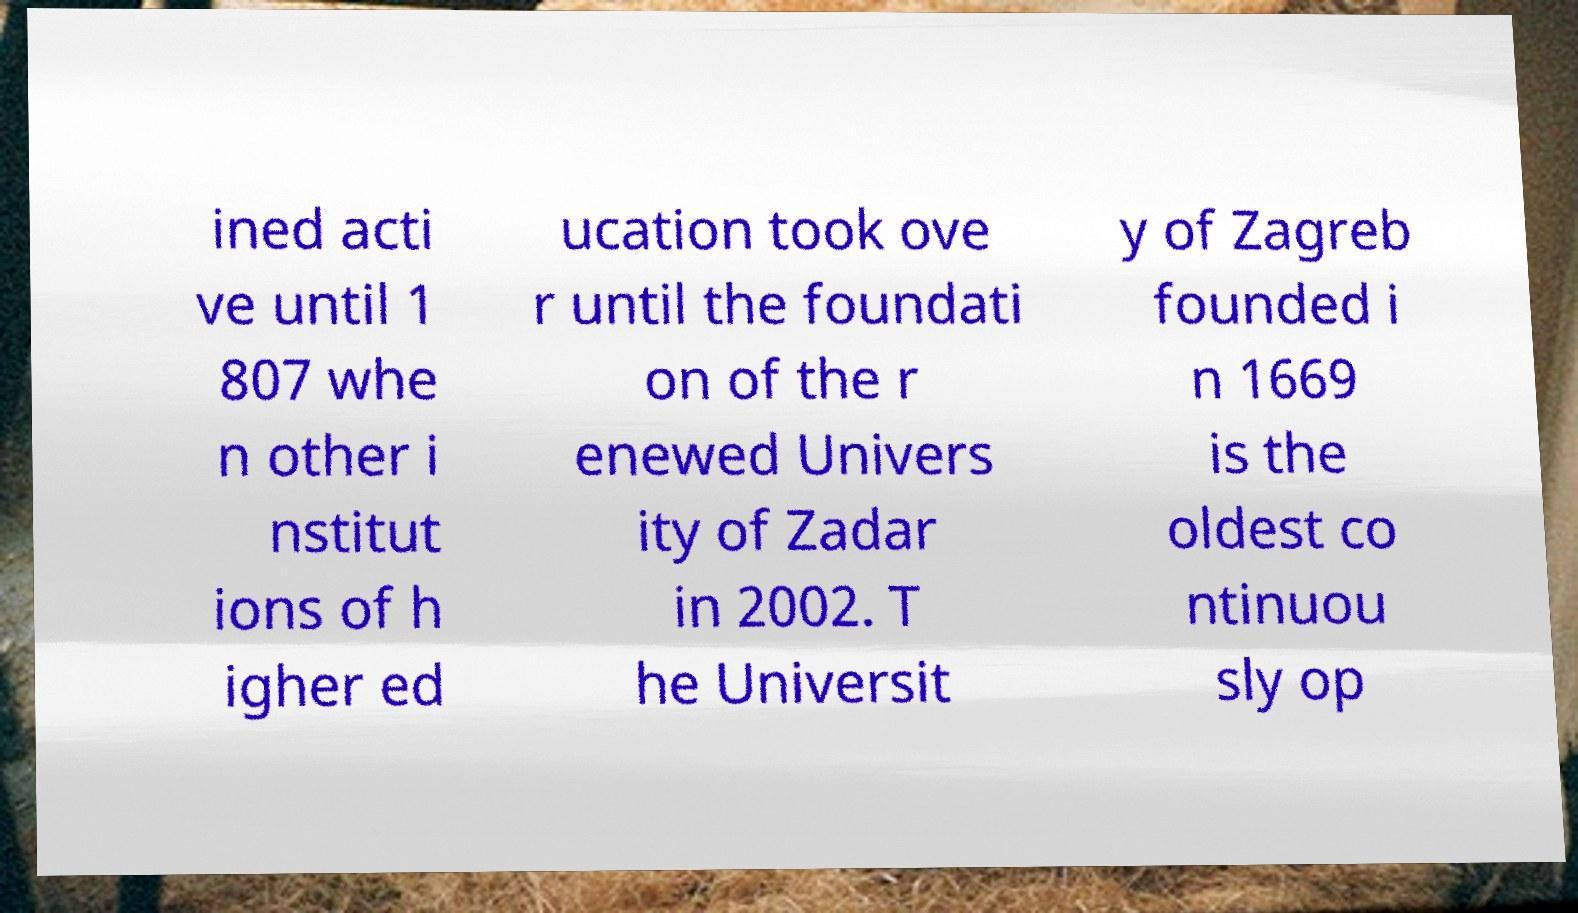For documentation purposes, I need the text within this image transcribed. Could you provide that? ined acti ve until 1 807 whe n other i nstitut ions of h igher ed ucation took ove r until the foundati on of the r enewed Univers ity of Zadar in 2002. T he Universit y of Zagreb founded i n 1669 is the oldest co ntinuou sly op 